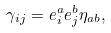<formula> <loc_0><loc_0><loc_500><loc_500>\gamma _ { i j } = e _ { i } ^ { a } e _ { j } ^ { b } \eta _ { a b } ,</formula> 